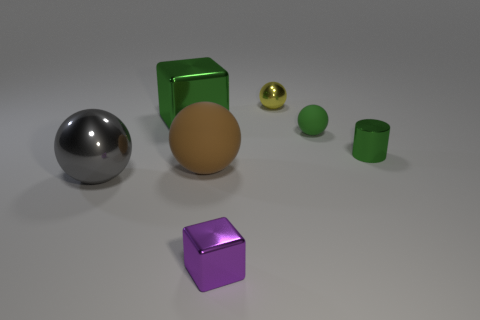Is there a green shiny object that has the same size as the green sphere?
Your answer should be compact. Yes. Is the material of the brown object the same as the tiny ball that is in front of the big block?
Give a very brief answer. Yes. What material is the thing in front of the large gray metal sphere?
Keep it short and to the point. Metal. What size is the brown rubber sphere?
Your answer should be very brief. Large. There is a purple metallic block left of the tiny green metal thing; does it have the same size as the metallic sphere that is in front of the yellow shiny ball?
Offer a very short reply. No. There is another metallic thing that is the same shape as the big green thing; what is its size?
Provide a short and direct response. Small. Does the yellow thing have the same size as the purple metallic thing in front of the big green metal thing?
Your response must be concise. Yes. Is there a big green block on the right side of the block behind the small metallic block?
Ensure brevity in your answer.  No. What is the shape of the green shiny object to the left of the purple metallic thing?
Make the answer very short. Cube. What material is the tiny sphere that is the same color as the large metallic block?
Provide a short and direct response. Rubber. 